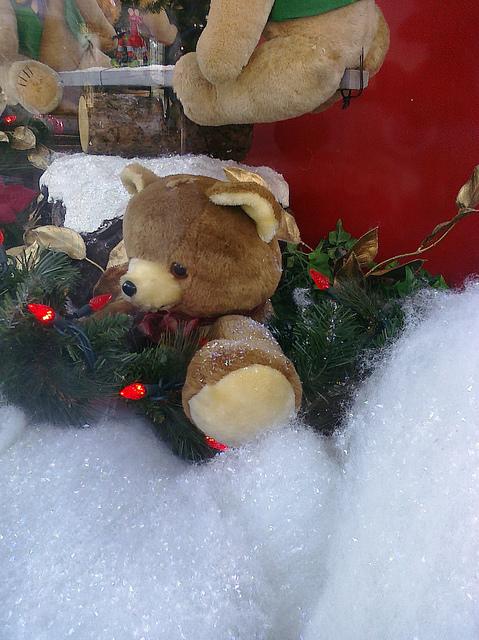Is the teddy bear celebrating Christmas?
Concise answer only. Yes. Is this a real animal?
Short answer required. No. What type of bear is this?
Short answer required. Teddy. 